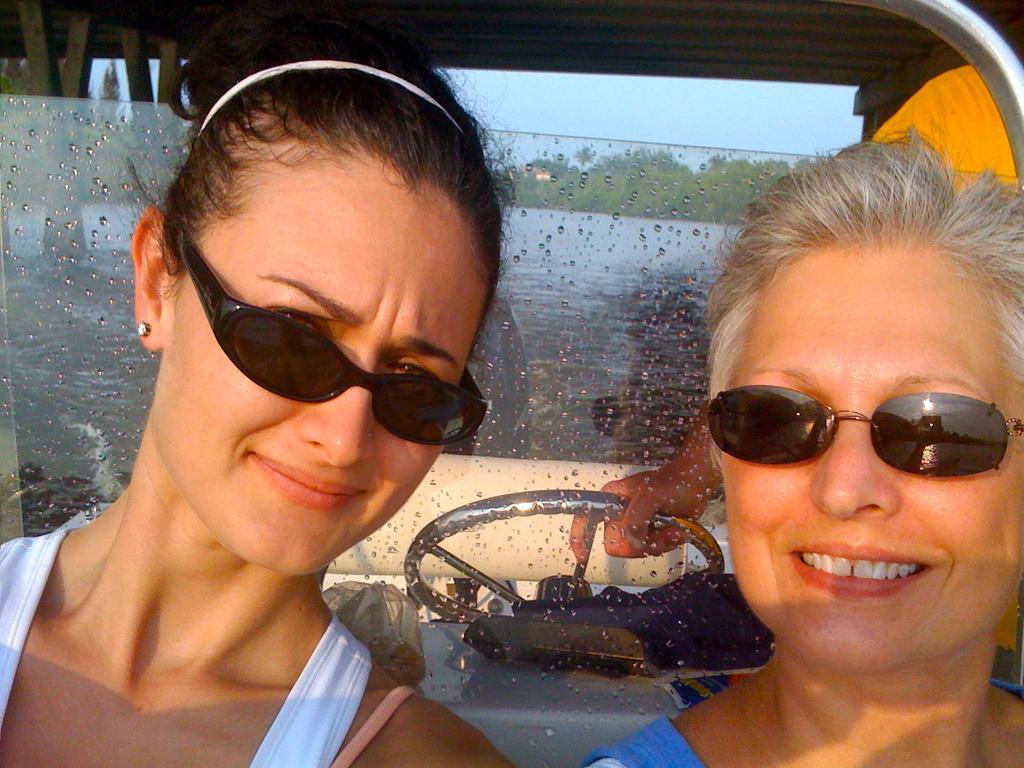How would you summarize this image in a sentence or two? In front of the picture, we see two women who are wearing goggles are smiling. Behind them, we see a steering wheel and the person in yellow T-shirt is holding the steering wheel. This picture might be clicked inside the vehicle. Behind them, we see glass from which we can see trees. 